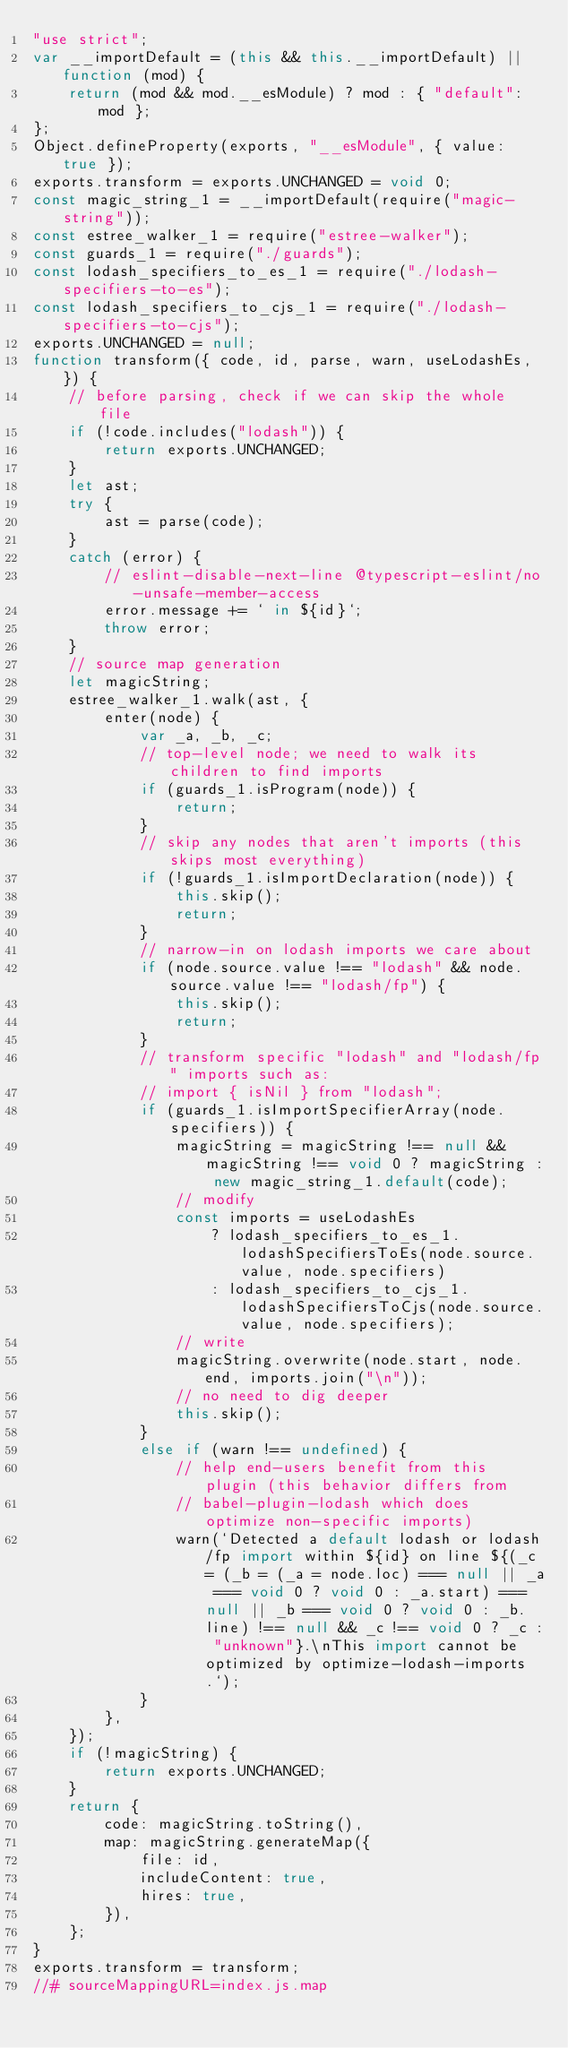<code> <loc_0><loc_0><loc_500><loc_500><_JavaScript_>"use strict";
var __importDefault = (this && this.__importDefault) || function (mod) {
    return (mod && mod.__esModule) ? mod : { "default": mod };
};
Object.defineProperty(exports, "__esModule", { value: true });
exports.transform = exports.UNCHANGED = void 0;
const magic_string_1 = __importDefault(require("magic-string"));
const estree_walker_1 = require("estree-walker");
const guards_1 = require("./guards");
const lodash_specifiers_to_es_1 = require("./lodash-specifiers-to-es");
const lodash_specifiers_to_cjs_1 = require("./lodash-specifiers-to-cjs");
exports.UNCHANGED = null;
function transform({ code, id, parse, warn, useLodashEs, }) {
    // before parsing, check if we can skip the whole file
    if (!code.includes("lodash")) {
        return exports.UNCHANGED;
    }
    let ast;
    try {
        ast = parse(code);
    }
    catch (error) {
        // eslint-disable-next-line @typescript-eslint/no-unsafe-member-access
        error.message += ` in ${id}`;
        throw error;
    }
    // source map generation
    let magicString;
    estree_walker_1.walk(ast, {
        enter(node) {
            var _a, _b, _c;
            // top-level node; we need to walk its children to find imports
            if (guards_1.isProgram(node)) {
                return;
            }
            // skip any nodes that aren't imports (this skips most everything)
            if (!guards_1.isImportDeclaration(node)) {
                this.skip();
                return;
            }
            // narrow-in on lodash imports we care about
            if (node.source.value !== "lodash" && node.source.value !== "lodash/fp") {
                this.skip();
                return;
            }
            // transform specific "lodash" and "lodash/fp" imports such as:
            // import { isNil } from "lodash";
            if (guards_1.isImportSpecifierArray(node.specifiers)) {
                magicString = magicString !== null && magicString !== void 0 ? magicString : new magic_string_1.default(code);
                // modify
                const imports = useLodashEs
                    ? lodash_specifiers_to_es_1.lodashSpecifiersToEs(node.source.value, node.specifiers)
                    : lodash_specifiers_to_cjs_1.lodashSpecifiersToCjs(node.source.value, node.specifiers);
                // write
                magicString.overwrite(node.start, node.end, imports.join("\n"));
                // no need to dig deeper
                this.skip();
            }
            else if (warn !== undefined) {
                // help end-users benefit from this plugin (this behavior differs from
                // babel-plugin-lodash which does optimize non-specific imports)
                warn(`Detected a default lodash or lodash/fp import within ${id} on line ${(_c = (_b = (_a = node.loc) === null || _a === void 0 ? void 0 : _a.start) === null || _b === void 0 ? void 0 : _b.line) !== null && _c !== void 0 ? _c : "unknown"}.\nThis import cannot be optimized by optimize-lodash-imports.`);
            }
        },
    });
    if (!magicString) {
        return exports.UNCHANGED;
    }
    return {
        code: magicString.toString(),
        map: magicString.generateMap({
            file: id,
            includeContent: true,
            hires: true,
        }),
    };
}
exports.transform = transform;
//# sourceMappingURL=index.js.map</code> 